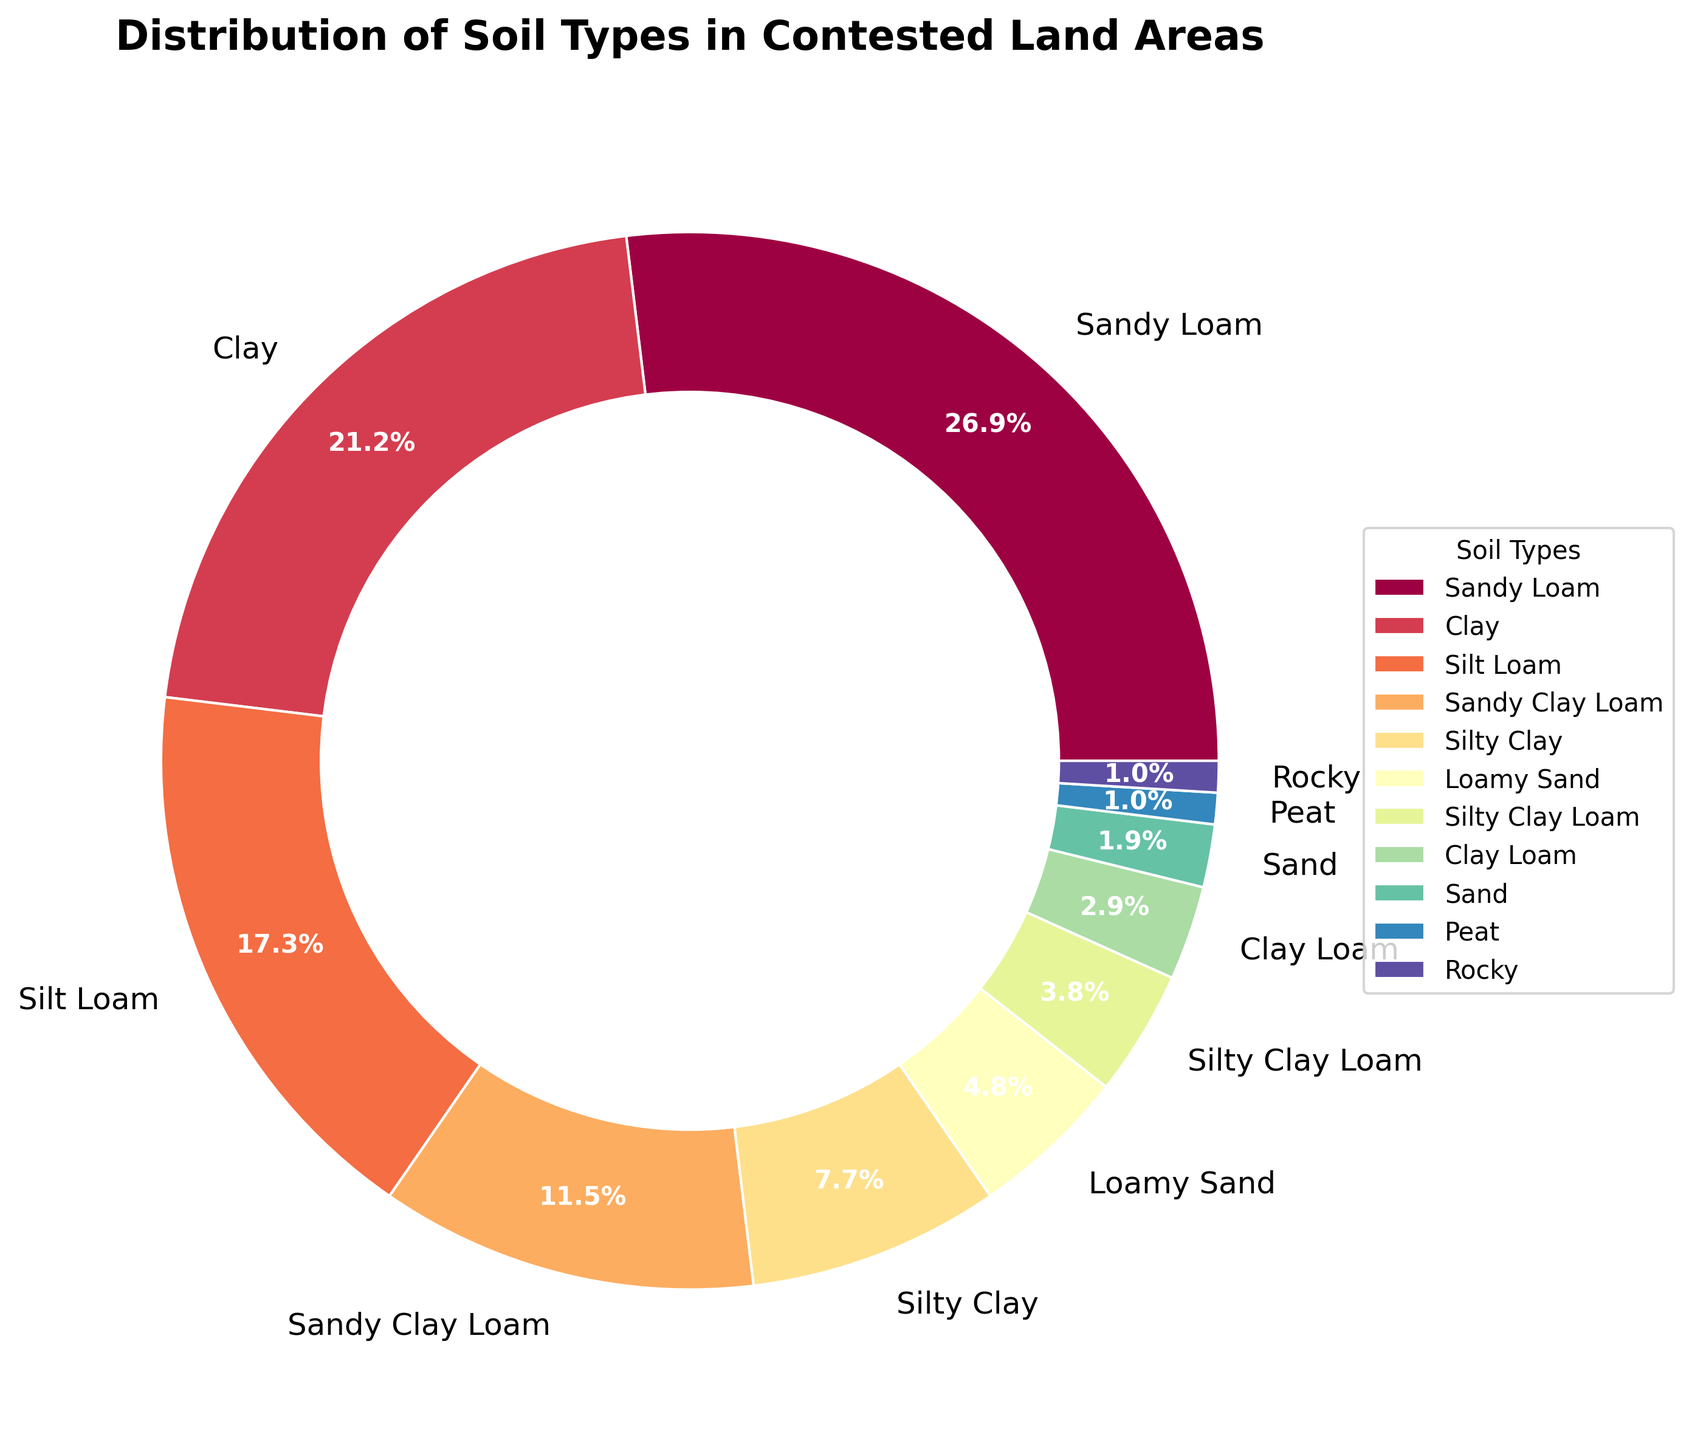What's the most common soil type in the contested land areas? The figure shows a pie chart depicting the distribution of soil types. The largest wedge represents Sandy Loam at 28%.
Answer: Sandy Loam Which soil type covers the second-highest area? By observing the pie chart, the wedge representing Clay is the second largest at 22%.
Answer: Clay What is the combined percentage of Silt Loam and Silty Clay? The percentages for Silt Loam and Silty Clay are 18% and 8%, respectively. Summing them up gives 18% + 8% = 26%.
Answer: 26% How does the area covered by Clay compare to that covered by Sand? The percentage of Clay is 22%, while Sand covers 2%. Comparing these, Clay covers a significantly larger area than Sand.
Answer: Clay covers a larger area Which two soil types cover the smallest areas? The pie chart shows that Peat and Rocky each cover only 1%, making them the smallest areas.
Answer: Peat and Rocky What is the difference in the area covered between Loamy Sand and Sandy Clay Loam? The percentages are 5% for Loamy Sand and 12% for Sandy Clay Loam. The difference is 12% - 5% = 7%.
Answer: 7% What is the total percentage of all soil types other than the top three? Top three soils (Sandy Loam, Clay, Silt Loam) cover 28% + 22% + 18% = 68%. Remaining percentage is 100% - 68% = 32%.
Answer: 32% Which soil type, among the less common ones, has a percentage just above Silty Clay Loam? Sandy Clay Loam is the less common soil type with its percentage (12%) just above Silty Clay Loam (4%).
Answer: Sandy Clay Loam What color represents Silty Clay on the pie chart? Observing the color mapping in the pie chart, Silty Clay is represented by a specific color that needs to be identified visually.
Answer: [Exact color from the chart] If Sandy Loam and Clay contributions increased by 2% each, what would be their new percentages? Adding 2% to both Sandy Loam and Clay: 28% + 2% = 30% for Sandy Loam; 22% + 2% = 24% for Clay.
Answer: Sandy Loam: 30%, Clay: 24% 